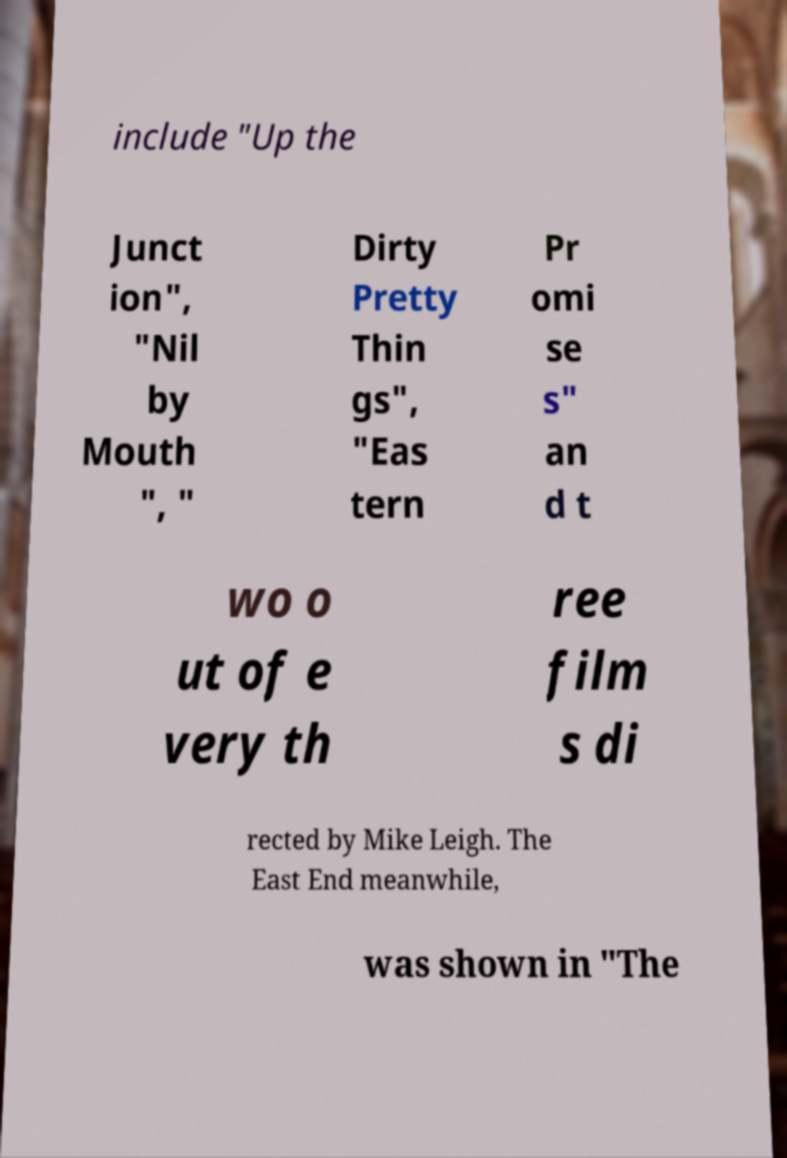There's text embedded in this image that I need extracted. Can you transcribe it verbatim? include "Up the Junct ion", "Nil by Mouth ", " Dirty Pretty Thin gs", "Eas tern Pr omi se s" an d t wo o ut of e very th ree film s di rected by Mike Leigh. The East End meanwhile, was shown in "The 